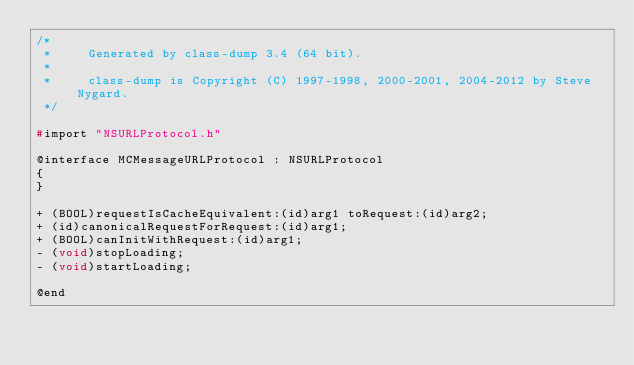<code> <loc_0><loc_0><loc_500><loc_500><_C_>/*
 *     Generated by class-dump 3.4 (64 bit).
 *
 *     class-dump is Copyright (C) 1997-1998, 2000-2001, 2004-2012 by Steve Nygard.
 */

#import "NSURLProtocol.h"

@interface MCMessageURLProtocol : NSURLProtocol
{
}

+ (BOOL)requestIsCacheEquivalent:(id)arg1 toRequest:(id)arg2;
+ (id)canonicalRequestForRequest:(id)arg1;
+ (BOOL)canInitWithRequest:(id)arg1;
- (void)stopLoading;
- (void)startLoading;

@end

</code> 